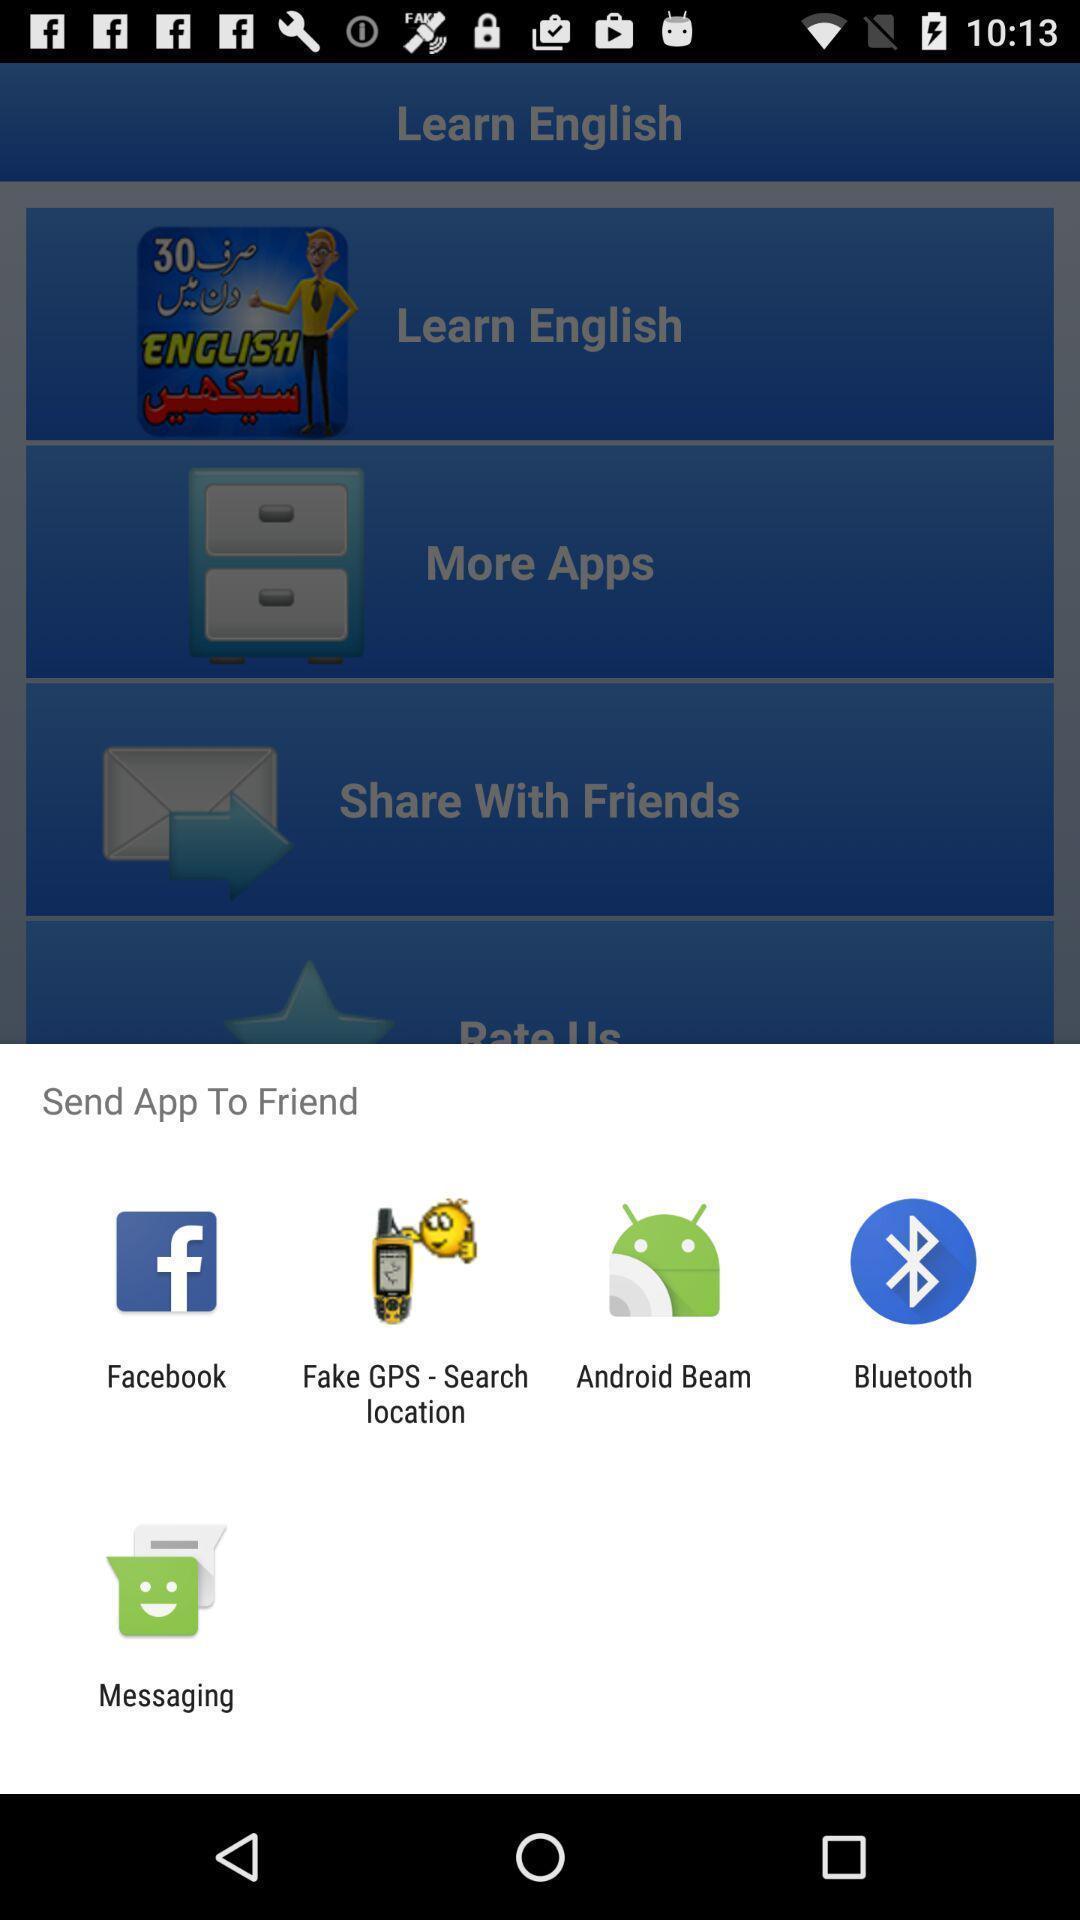Give me a summary of this screen capture. Pop-up showing various sharing options to send an app. 